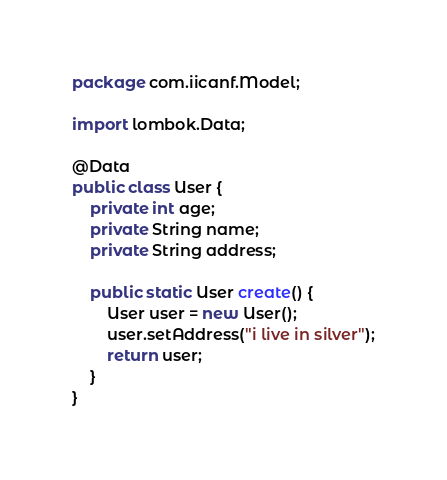Convert code to text. <code><loc_0><loc_0><loc_500><loc_500><_Java_>package com.iicanf.Model;

import lombok.Data;

@Data
public class User {
    private int age;
    private String name;
    private String address;

    public static User create() {
        User user = new User();
        user.setAddress("i live in silver");
        return user;
    }
}
</code> 